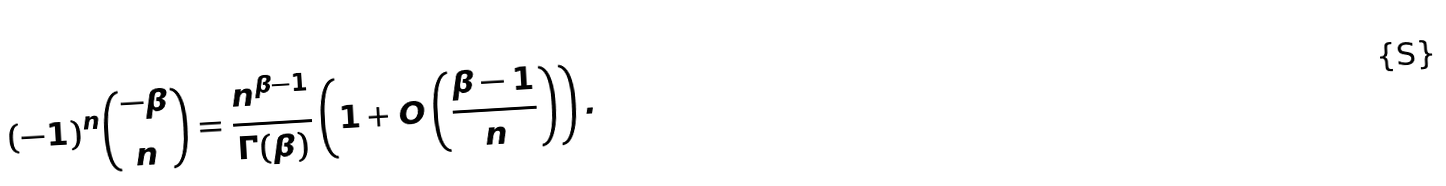<formula> <loc_0><loc_0><loc_500><loc_500>( - 1 ) ^ { n } \binom { - \beta } { n } = \frac { n ^ { \beta - 1 } } { \Gamma ( \beta ) } \left ( 1 + O \left ( \frac { \beta - 1 } { n } \right ) \right ) .</formula> 